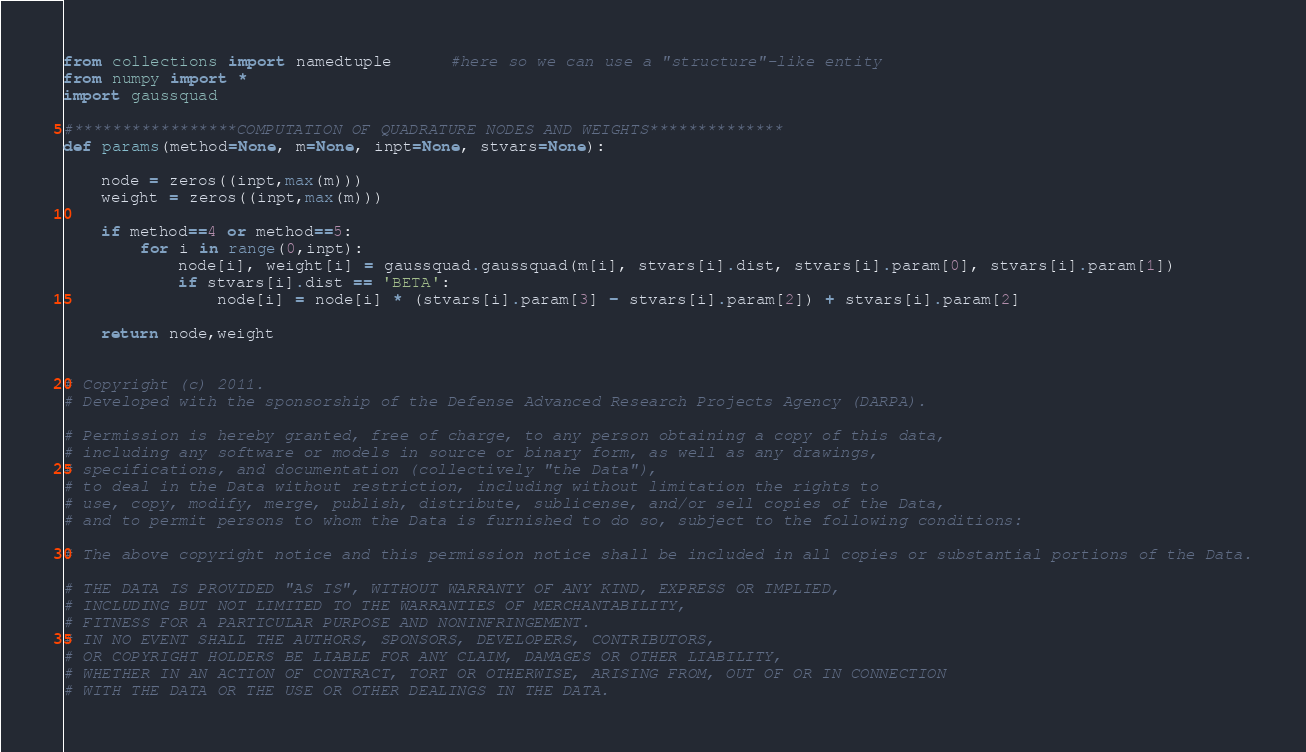Convert code to text. <code><loc_0><loc_0><loc_500><loc_500><_Python_>from collections import namedtuple      #here so we can use a "structure"-like entity
from numpy import *
import gaussquad

#*****************COMPUTATION OF QUADRATURE NODES AND WEIGHTS**************
def params(method=None, m=None, inpt=None, stvars=None):
    
    node = zeros((inpt,max(m)))
    weight = zeros((inpt,max(m)))

    if method==4 or method==5:    
        for i in range(0,inpt):
            node[i], weight[i] = gaussquad.gaussquad(m[i], stvars[i].dist, stvars[i].param[0], stvars[i].param[1])
            if stvars[i].dist == 'BETA':     
                node[i] = node[i] * (stvars[i].param[3] - stvars[i].param[2]) + stvars[i].param[2]    
    
    return node,weight
    
    
# Copyright (c) 2011.
# Developed with the sponsorship of the Defense Advanced Research Projects Agency (DARPA).

# Permission is hereby granted, free of charge, to any person obtaining a copy of this data,
# including any software or models in source or binary form, as well as any drawings,
# specifications, and documentation (collectively "the Data"),
# to deal in the Data without restriction, including without limitation the rights to
# use, copy, modify, merge, publish, distribute, sublicense, and/or sell copies of the Data,
# and to permit persons to whom the Data is furnished to do so, subject to the following conditions:

# The above copyright notice and this permission notice shall be included in all copies or substantial portions of the Data.

# THE DATA IS PROVIDED "AS IS", WITHOUT WARRANTY OF ANY KIND, EXPRESS OR IMPLIED,
# INCLUDING BUT NOT LIMITED TO THE WARRANTIES OF MERCHANTABILITY,
# FITNESS FOR A PARTICULAR PURPOSE AND NONINFRINGEMENT.
# IN NO EVENT SHALL THE AUTHORS, SPONSORS, DEVELOPERS, CONTRIBUTORS,
# OR COPYRIGHT HOLDERS BE LIABLE FOR ANY CLAIM, DAMAGES OR OTHER LIABILITY,
# WHETHER IN AN ACTION OF CONTRACT, TORT OR OTHERWISE, ARISING FROM, OUT OF OR IN CONNECTION
# WITH THE DATA OR THE USE OR OTHER DEALINGS IN THE DATA.


</code> 